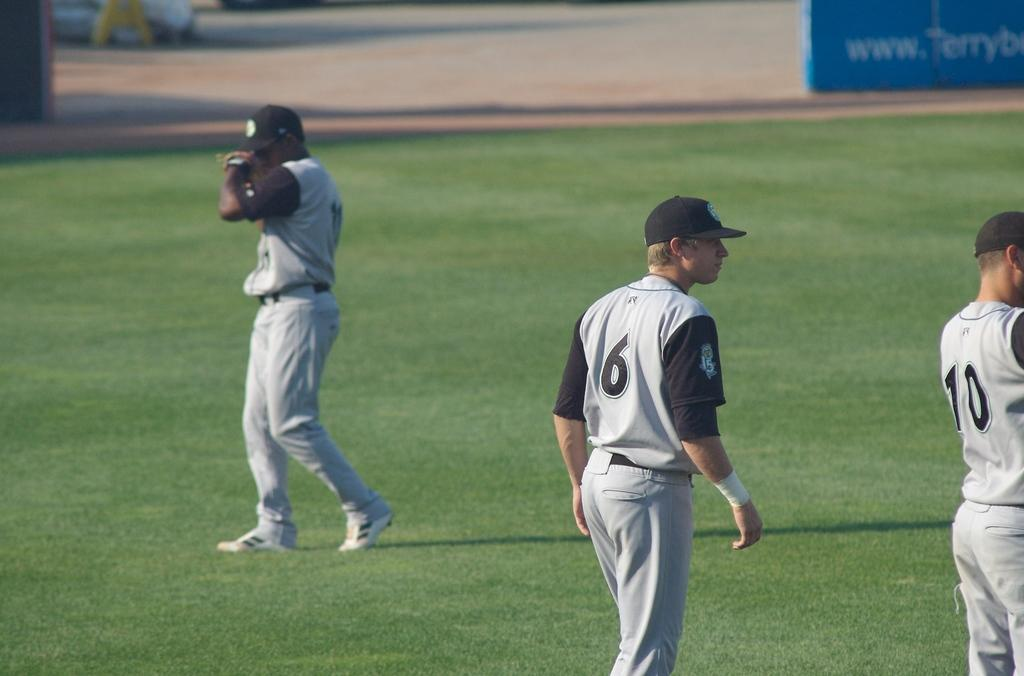<image>
Provide a brief description of the given image. Baseball team at practice on a field with player 6 in the center. 